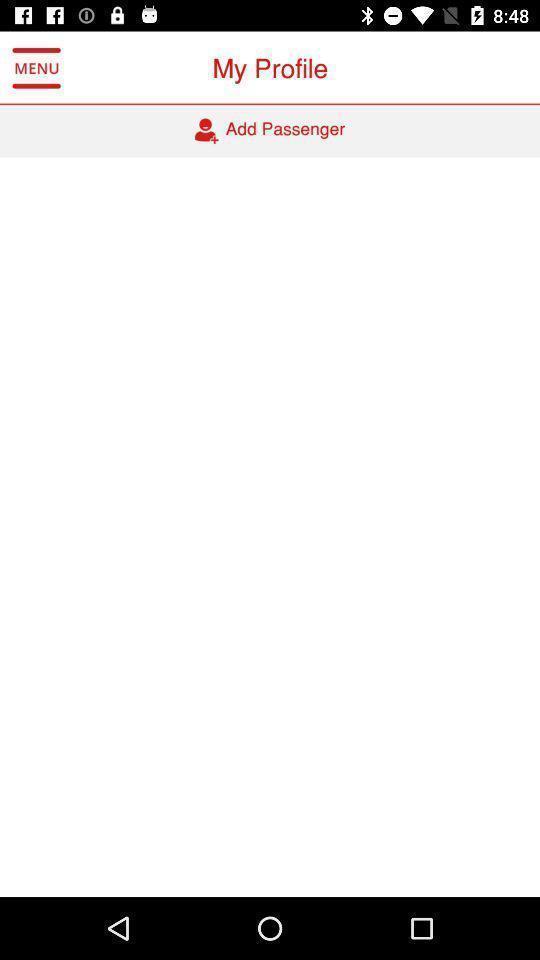Give me a summary of this screen capture. Screen shows profile. 